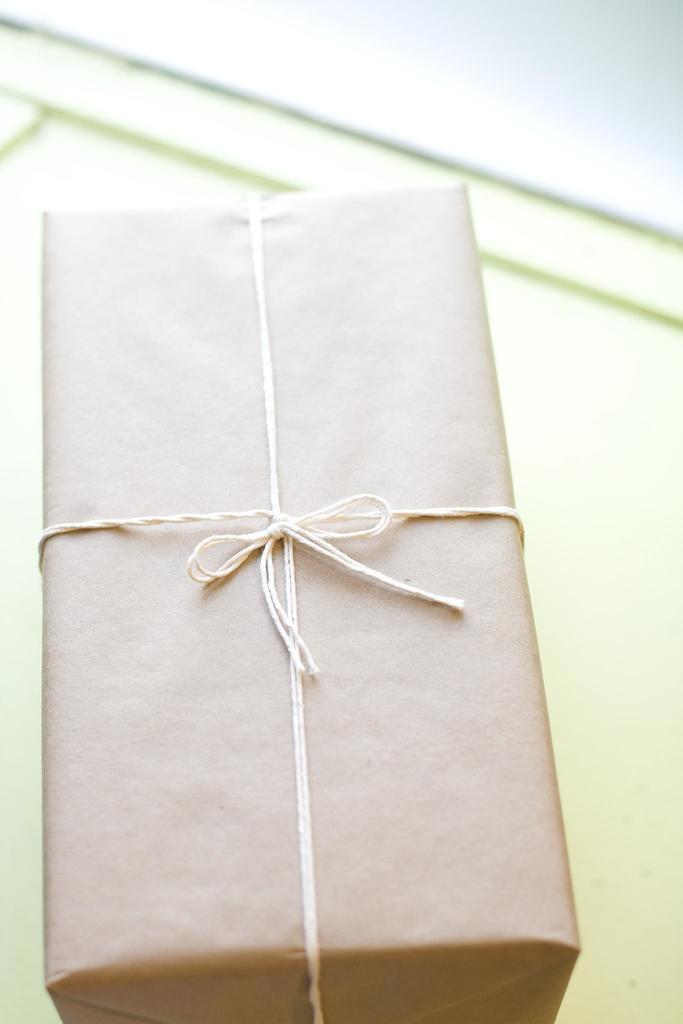What object is present on the table in the image? There is a box on the table in the image. How is the box secured or fastened? The box is tied with a white thread. What type of marble is used to decorate the box in the image? There is no marble present on the box in the image; it is tied with a white thread. 